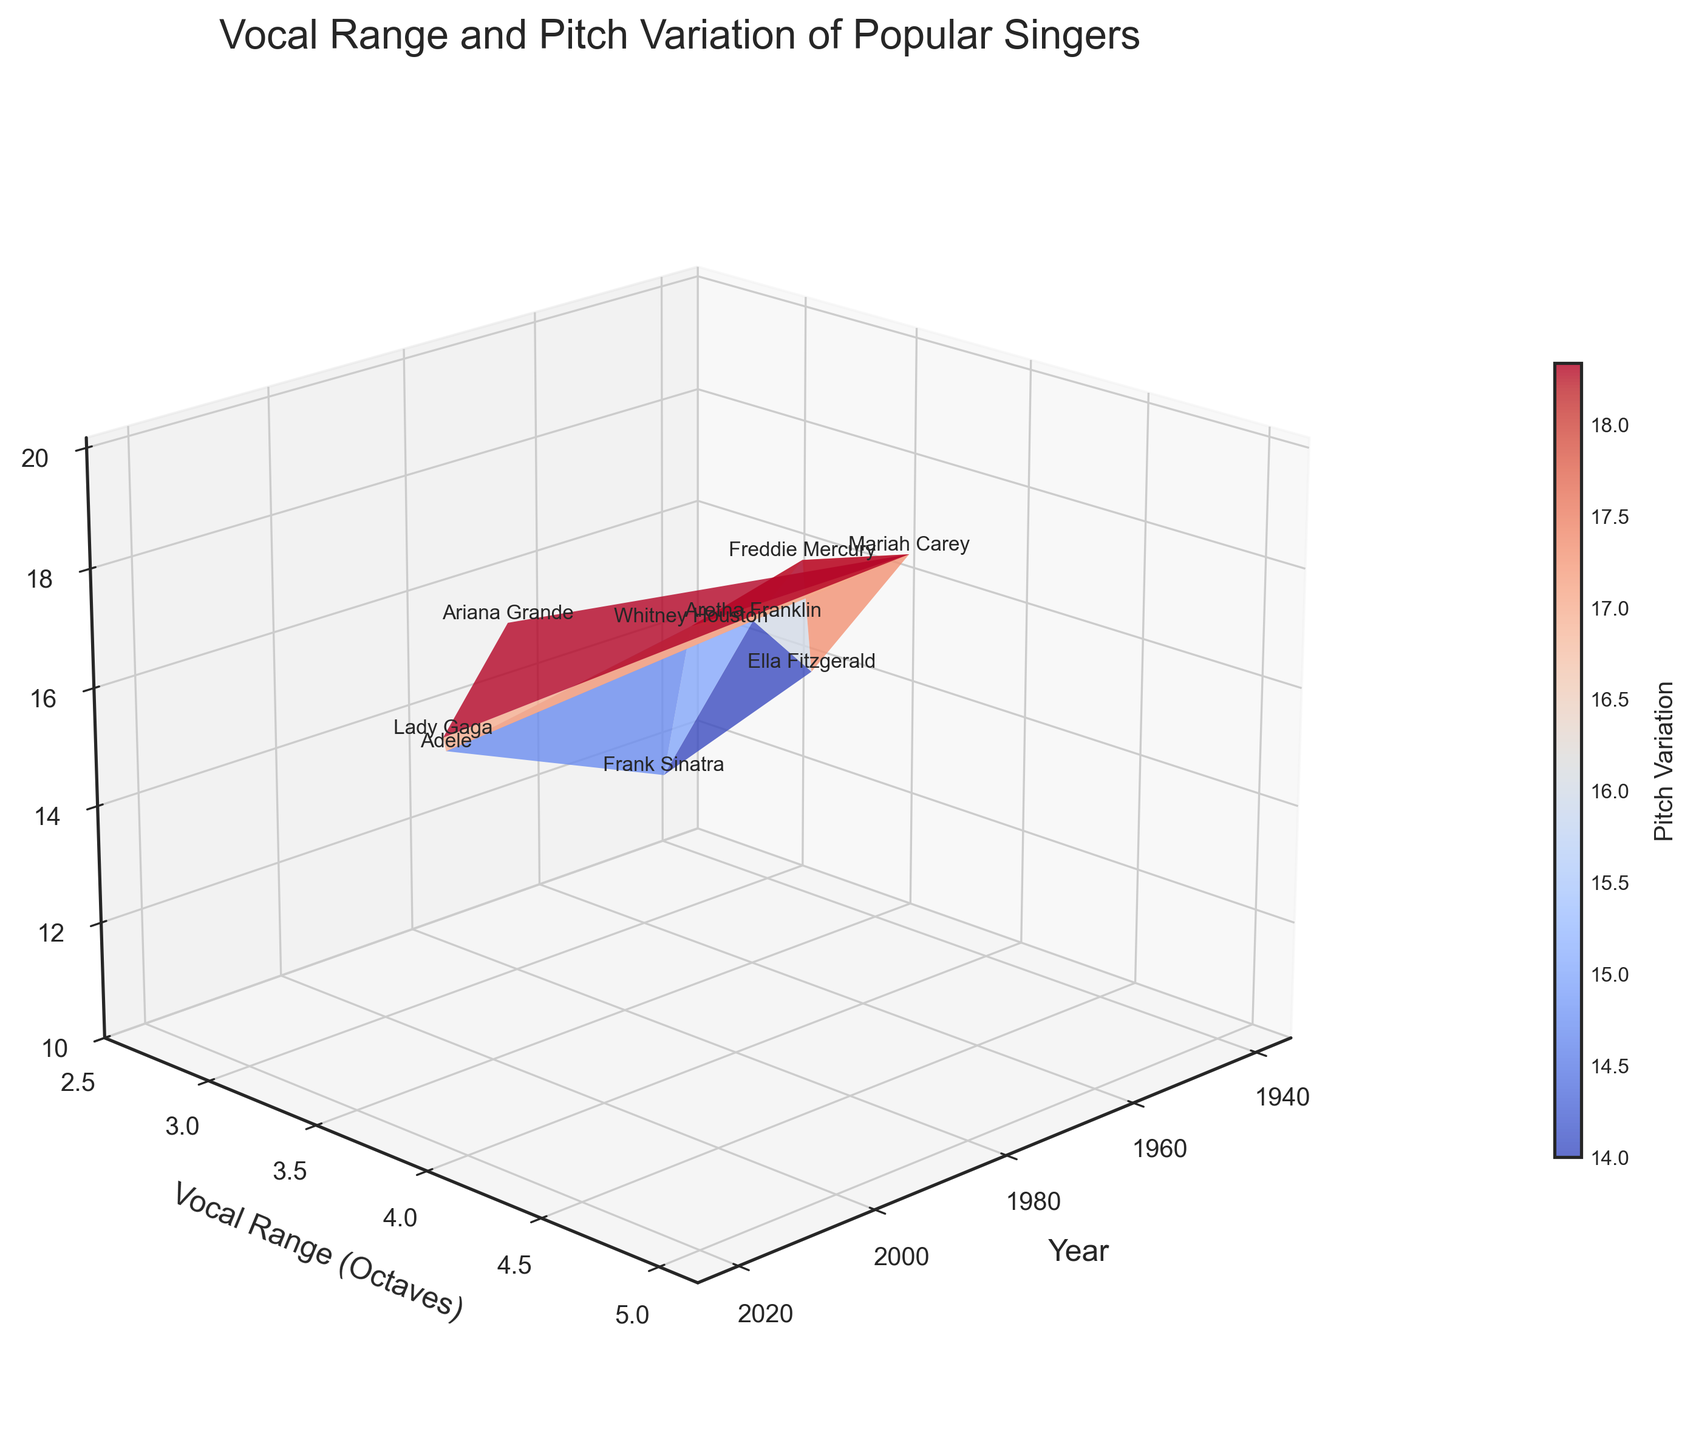What's the title of the plot? The title is displayed prominently at the top of the plot, giving the viewer an overview of the plot's focus. In this case, it reads "Vocal Range and Pitch Variation of Popular Singers."
Answer: Vocal Range and Pitch Variation of Popular Singers How many singers are represented in the plot? Counting the number of data points or labels corresponding to each singer's name on the plot indicates the number of singers. There are nine data points.
Answer: Nine What are the three axes of the plot labeled as? The labels for the three axes are directly visible on the plot. They typically appear alongside the respective axes. Here, they are "Year" for the X-axis, "Vocal Range (Octaves)" for the Y-axis, and "Pitch Variation (Semitones)" for the Z-axis.
Answer: Year, Vocal Range (Octaves), Pitch Variation (Semitones) Which singer has the highest vocal range? To determine this, look for the highest point on the Vocal Range axis and check the label corresponding to that data point. The highest range is 5.0 octaves, which belongs to Mariah Carey.
Answer: Mariah Carey What is the pitch variation range of Whitney Houston? By locating Whitney Houston's data point on the plot, you can see the height on the Pitch Variation axis. Her pitch variation is 17 semitones.
Answer: 17 semitones How does Ariana Grande's vocal range compare to Freddie Mercury's? Comparing their positions on the Vocal Range axis reveals that Ariana Grande has a vocal range of 4.2 octaves, while Freddie Mercury has 4.0 octaves. Hence, Ariana Grande has a slightly wider range.
Answer: Ariana Grande's range is slightly wider by 0.2 octaves Which singer from the 1940s is represented, and what are their vocal range and pitch variation? Locate the data point for the year 1940 and check the corresponding information. The singer is Ella Fitzgerald, with a vocal range of 3.2 octaves and a pitch variation of 14 semitones.
Answer: Ella Fitzgerald, 3.2 octaves, 14 semitones What can be said about the trend of vocal ranges from the 1940s to 2020? Observing the plot's vocal range axis from 1940 to 2020, we notice an overall increase, with Mariah Carey's peak in the 1990s and Ariana Grande's high range in 2020.
Answer: Generally, there is an increasing trend How does the pitch variation of singers in the 1980s compare to those in the 2020s? Comparing data points from the 1980s (Whitney Houston with 17 semitones) and 2020s (Ariana Grande with 19 semitones) shows that pitch variation has increased over time.
Answer: Higher in the 2020s by 2 semitones Which singer has the greatest combined value of vocal range and pitch variation? Calculate the sum of the vocal range and pitch variation for each singer and compare. Mariah Carey stands out with a combined value of 5.0 + 20 = 25.
Answer: Mariah Carey 